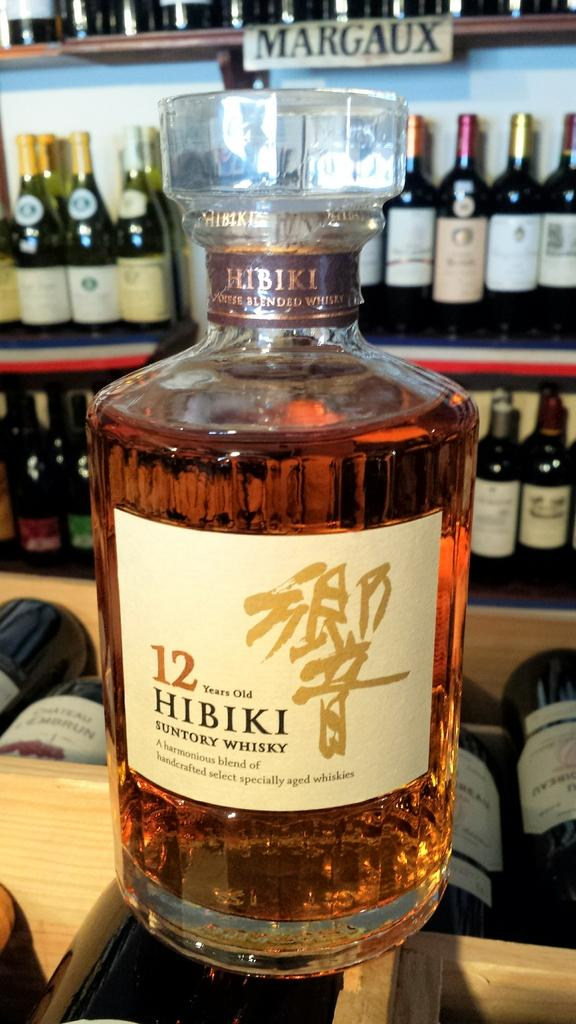What type of alcoholic beverage is featured in the image? There is a whiskey bottle in the image. Where are the wine bottles located in the image? The wine bottles are on a shelf in the image. How many girls are sitting on the banana in the image? There are no girls or bananas present in the image. 